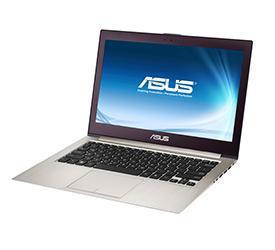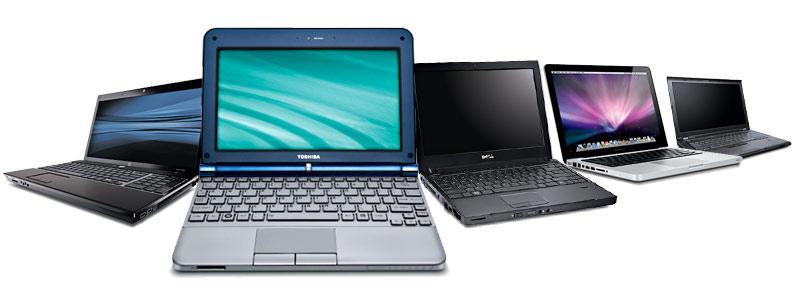The first image is the image on the left, the second image is the image on the right. For the images displayed, is the sentence "An image shows at least five laptops." factually correct? Answer yes or no. Yes. The first image is the image on the left, the second image is the image on the right. Assess this claim about the two images: "At least five laptop computer styles are arrayed in one image.". Correct or not? Answer yes or no. Yes. 